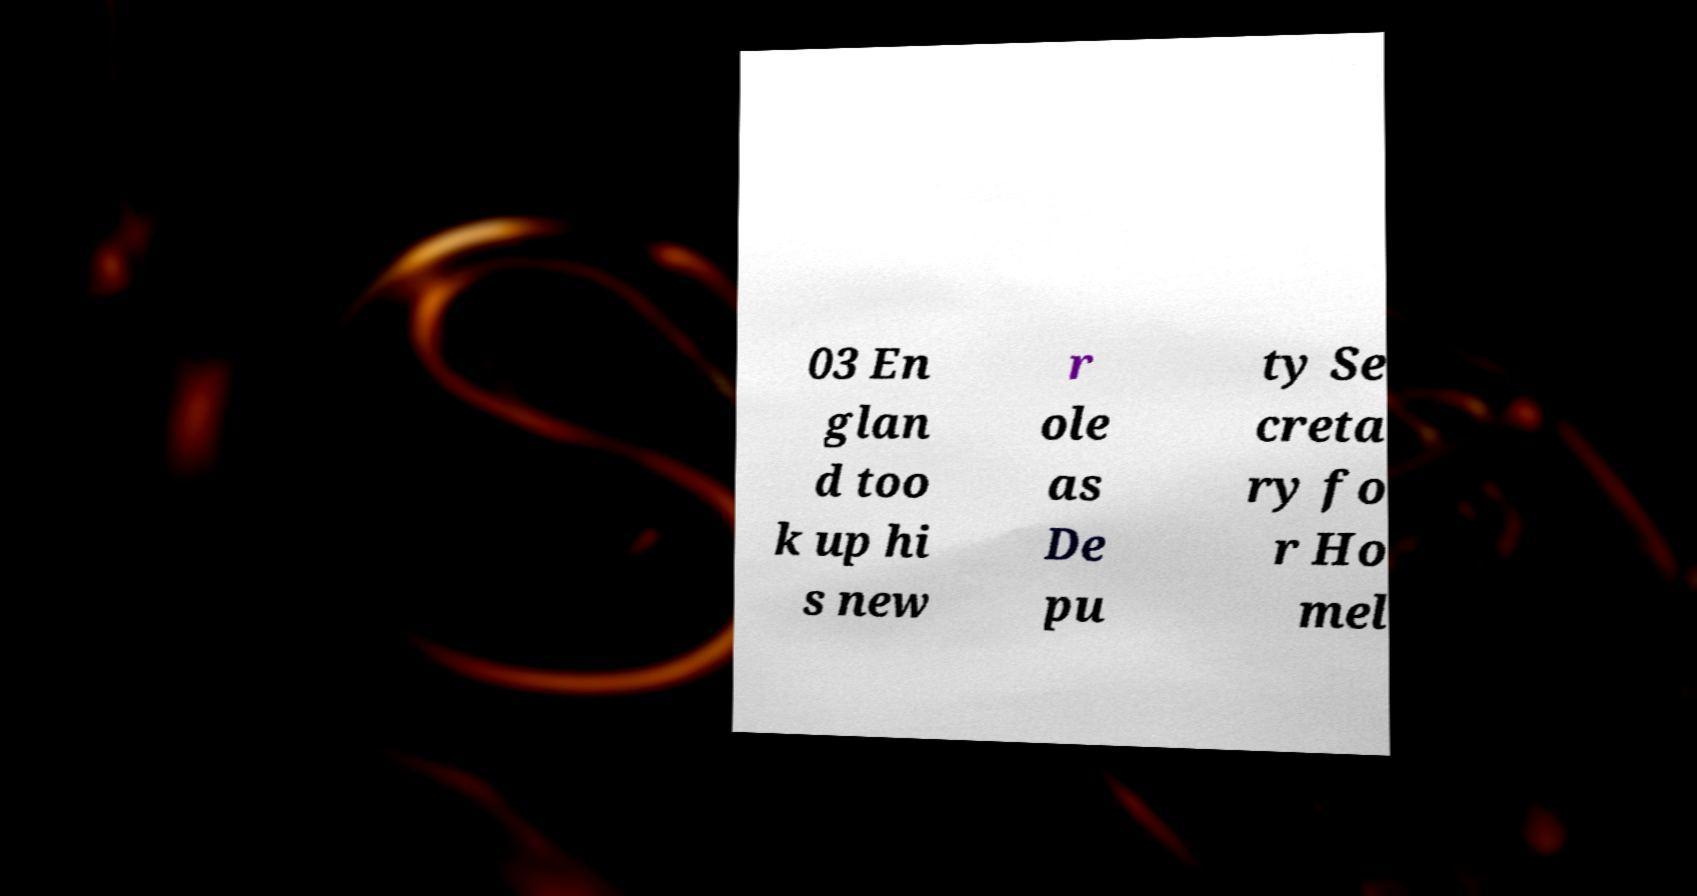For documentation purposes, I need the text within this image transcribed. Could you provide that? 03 En glan d too k up hi s new r ole as De pu ty Se creta ry fo r Ho mel 